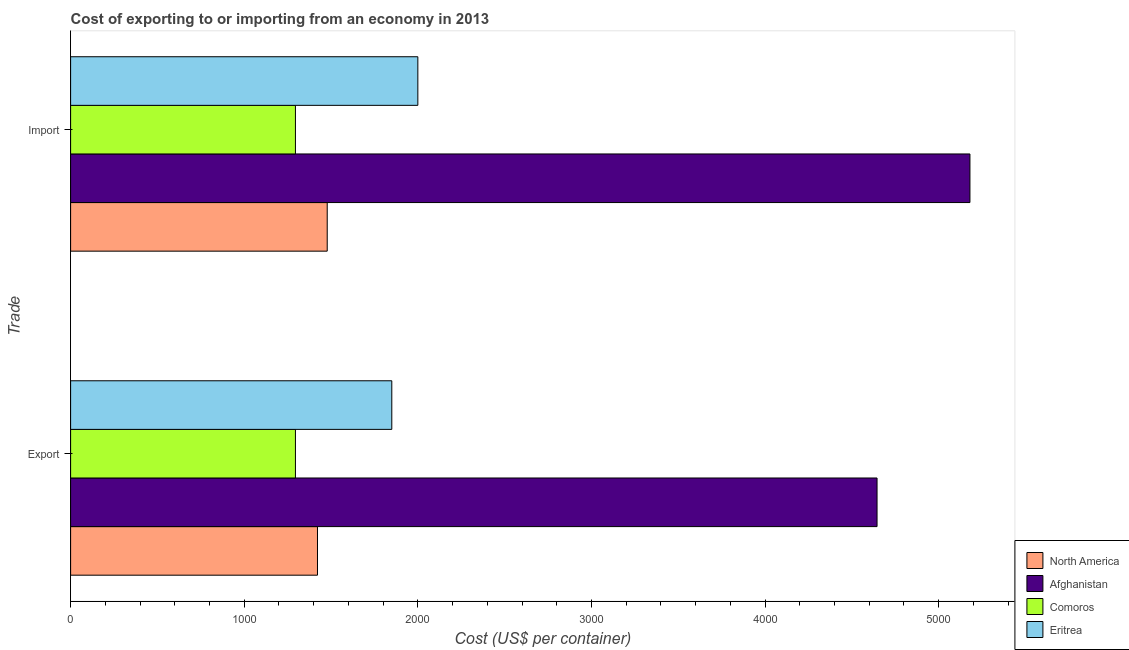Are the number of bars per tick equal to the number of legend labels?
Keep it short and to the point. Yes. What is the label of the 2nd group of bars from the top?
Offer a terse response. Export. What is the import cost in Comoros?
Your response must be concise. 1295. Across all countries, what is the maximum export cost?
Your response must be concise. 4645. Across all countries, what is the minimum export cost?
Your answer should be very brief. 1295. In which country was the export cost maximum?
Your answer should be very brief. Afghanistan. In which country was the import cost minimum?
Your response must be concise. Comoros. What is the total export cost in the graph?
Your answer should be very brief. 9212. What is the difference between the import cost in North America and that in Eritrea?
Your response must be concise. -522. What is the difference between the import cost in Eritrea and the export cost in Comoros?
Provide a succinct answer. 705. What is the average import cost per country?
Provide a succinct answer. 2488.25. What is the difference between the export cost and import cost in North America?
Offer a very short reply. -56. In how many countries, is the export cost greater than 3800 US$?
Give a very brief answer. 1. What is the ratio of the export cost in Comoros to that in Afghanistan?
Make the answer very short. 0.28. In how many countries, is the import cost greater than the average import cost taken over all countries?
Your answer should be compact. 1. What does the 1st bar from the bottom in Import represents?
Your response must be concise. North America. How many bars are there?
Your answer should be very brief. 8. Are all the bars in the graph horizontal?
Your response must be concise. Yes. What is the difference between two consecutive major ticks on the X-axis?
Provide a succinct answer. 1000. Does the graph contain any zero values?
Offer a very short reply. No. Does the graph contain grids?
Ensure brevity in your answer.  No. Where does the legend appear in the graph?
Offer a terse response. Bottom right. How are the legend labels stacked?
Ensure brevity in your answer.  Vertical. What is the title of the graph?
Make the answer very short. Cost of exporting to or importing from an economy in 2013. What is the label or title of the X-axis?
Give a very brief answer. Cost (US$ per container). What is the label or title of the Y-axis?
Provide a short and direct response. Trade. What is the Cost (US$ per container) of North America in Export?
Ensure brevity in your answer.  1422. What is the Cost (US$ per container) of Afghanistan in Export?
Offer a terse response. 4645. What is the Cost (US$ per container) in Comoros in Export?
Provide a short and direct response. 1295. What is the Cost (US$ per container) of Eritrea in Export?
Offer a terse response. 1850. What is the Cost (US$ per container) in North America in Import?
Provide a short and direct response. 1478. What is the Cost (US$ per container) in Afghanistan in Import?
Offer a terse response. 5180. What is the Cost (US$ per container) in Comoros in Import?
Your answer should be very brief. 1295. Across all Trade, what is the maximum Cost (US$ per container) in North America?
Your response must be concise. 1478. Across all Trade, what is the maximum Cost (US$ per container) in Afghanistan?
Provide a short and direct response. 5180. Across all Trade, what is the maximum Cost (US$ per container) in Comoros?
Offer a terse response. 1295. Across all Trade, what is the minimum Cost (US$ per container) of North America?
Provide a succinct answer. 1422. Across all Trade, what is the minimum Cost (US$ per container) in Afghanistan?
Your answer should be compact. 4645. Across all Trade, what is the minimum Cost (US$ per container) of Comoros?
Make the answer very short. 1295. Across all Trade, what is the minimum Cost (US$ per container) of Eritrea?
Offer a terse response. 1850. What is the total Cost (US$ per container) of North America in the graph?
Your response must be concise. 2900. What is the total Cost (US$ per container) in Afghanistan in the graph?
Keep it short and to the point. 9825. What is the total Cost (US$ per container) of Comoros in the graph?
Keep it short and to the point. 2590. What is the total Cost (US$ per container) of Eritrea in the graph?
Your response must be concise. 3850. What is the difference between the Cost (US$ per container) in North America in Export and that in Import?
Give a very brief answer. -56. What is the difference between the Cost (US$ per container) in Afghanistan in Export and that in Import?
Keep it short and to the point. -535. What is the difference between the Cost (US$ per container) of Comoros in Export and that in Import?
Your answer should be compact. 0. What is the difference between the Cost (US$ per container) of Eritrea in Export and that in Import?
Your answer should be compact. -150. What is the difference between the Cost (US$ per container) in North America in Export and the Cost (US$ per container) in Afghanistan in Import?
Provide a succinct answer. -3758. What is the difference between the Cost (US$ per container) of North America in Export and the Cost (US$ per container) of Comoros in Import?
Your response must be concise. 127. What is the difference between the Cost (US$ per container) of North America in Export and the Cost (US$ per container) of Eritrea in Import?
Your answer should be very brief. -578. What is the difference between the Cost (US$ per container) in Afghanistan in Export and the Cost (US$ per container) in Comoros in Import?
Your response must be concise. 3350. What is the difference between the Cost (US$ per container) of Afghanistan in Export and the Cost (US$ per container) of Eritrea in Import?
Make the answer very short. 2645. What is the difference between the Cost (US$ per container) of Comoros in Export and the Cost (US$ per container) of Eritrea in Import?
Ensure brevity in your answer.  -705. What is the average Cost (US$ per container) in North America per Trade?
Provide a succinct answer. 1450. What is the average Cost (US$ per container) of Afghanistan per Trade?
Provide a succinct answer. 4912.5. What is the average Cost (US$ per container) of Comoros per Trade?
Keep it short and to the point. 1295. What is the average Cost (US$ per container) in Eritrea per Trade?
Your answer should be very brief. 1925. What is the difference between the Cost (US$ per container) in North America and Cost (US$ per container) in Afghanistan in Export?
Provide a succinct answer. -3223. What is the difference between the Cost (US$ per container) in North America and Cost (US$ per container) in Comoros in Export?
Ensure brevity in your answer.  127. What is the difference between the Cost (US$ per container) in North America and Cost (US$ per container) in Eritrea in Export?
Make the answer very short. -428. What is the difference between the Cost (US$ per container) of Afghanistan and Cost (US$ per container) of Comoros in Export?
Your answer should be very brief. 3350. What is the difference between the Cost (US$ per container) of Afghanistan and Cost (US$ per container) of Eritrea in Export?
Make the answer very short. 2795. What is the difference between the Cost (US$ per container) in Comoros and Cost (US$ per container) in Eritrea in Export?
Ensure brevity in your answer.  -555. What is the difference between the Cost (US$ per container) in North America and Cost (US$ per container) in Afghanistan in Import?
Make the answer very short. -3702. What is the difference between the Cost (US$ per container) of North America and Cost (US$ per container) of Comoros in Import?
Make the answer very short. 183. What is the difference between the Cost (US$ per container) in North America and Cost (US$ per container) in Eritrea in Import?
Give a very brief answer. -522. What is the difference between the Cost (US$ per container) in Afghanistan and Cost (US$ per container) in Comoros in Import?
Ensure brevity in your answer.  3885. What is the difference between the Cost (US$ per container) of Afghanistan and Cost (US$ per container) of Eritrea in Import?
Provide a succinct answer. 3180. What is the difference between the Cost (US$ per container) in Comoros and Cost (US$ per container) in Eritrea in Import?
Keep it short and to the point. -705. What is the ratio of the Cost (US$ per container) in North America in Export to that in Import?
Your answer should be compact. 0.96. What is the ratio of the Cost (US$ per container) of Afghanistan in Export to that in Import?
Keep it short and to the point. 0.9. What is the ratio of the Cost (US$ per container) of Comoros in Export to that in Import?
Your answer should be very brief. 1. What is the ratio of the Cost (US$ per container) in Eritrea in Export to that in Import?
Your answer should be compact. 0.93. What is the difference between the highest and the second highest Cost (US$ per container) of North America?
Provide a succinct answer. 56. What is the difference between the highest and the second highest Cost (US$ per container) of Afghanistan?
Give a very brief answer. 535. What is the difference between the highest and the second highest Cost (US$ per container) in Comoros?
Your answer should be compact. 0. What is the difference between the highest and the second highest Cost (US$ per container) in Eritrea?
Offer a very short reply. 150. What is the difference between the highest and the lowest Cost (US$ per container) in Afghanistan?
Give a very brief answer. 535. What is the difference between the highest and the lowest Cost (US$ per container) in Eritrea?
Your answer should be very brief. 150. 